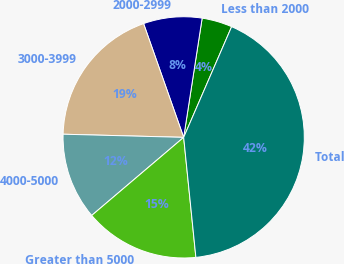Convert chart. <chart><loc_0><loc_0><loc_500><loc_500><pie_chart><fcel>Less than 2000<fcel>2000-2999<fcel>3000-3999<fcel>4000-5000<fcel>Greater than 5000<fcel>Total<nl><fcel>4.06%<fcel>7.84%<fcel>19.19%<fcel>11.62%<fcel>15.41%<fcel>41.88%<nl></chart> 